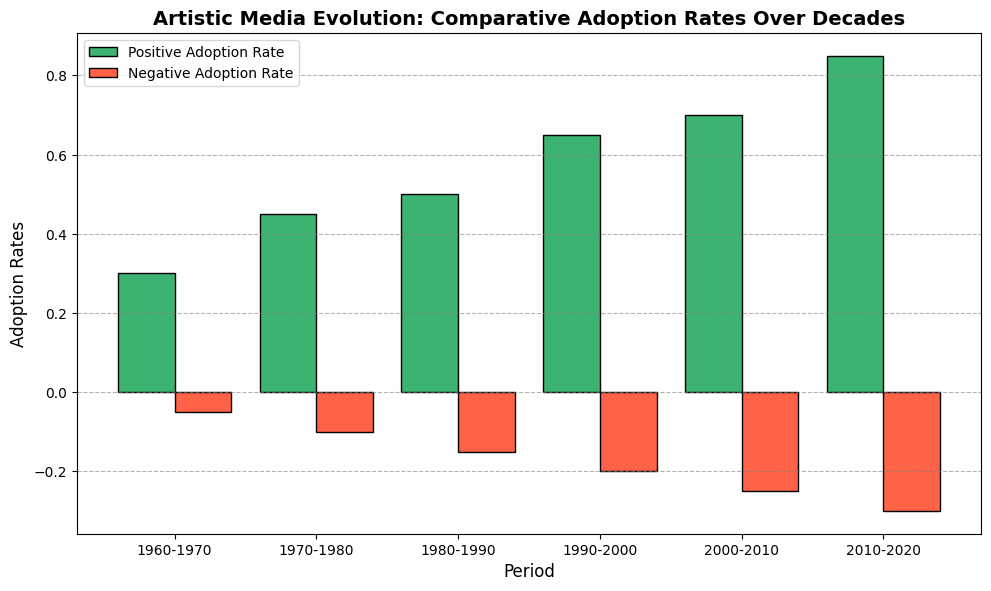How did the Positive Adoption Rate change from the 1960-1970 period to the 2010-2020 period? The Positive Adoption Rate in 1960-1970 was 0.30 and in 2010-2020 it was 0.85. Subtract 0.30 from 0.85 to find the change: 0.85 - 0.30 = 0.55
Answer: Increased by 0.55 During which period did the Negative Adoption Rate first exceed 0.20? By looking at the bar heights for negative adoption rates, the period 1990-2000 shows the Negative Adoption Rate reaching 0.20 for the first time
Answer: 1990-2000 What was the average Positive Adoption Rate across all periods? Add all the Positive Adoption Rates: 0.30 + 0.45 + 0.50 + 0.65 + 0.70 + 0.85, which equals 3.45. Divide by the number of periods, which is 6: 3.45 / 6 = 0.575
Answer: 0.575 Which period had the largest difference between Positive and Negative Adoption Rates? Calculate the differences for each period and compare:
- 1960-1970: 0.30 - 0.05 = 0.25
- 1970-1980: 0.45 - 0.10 = 0.35
- 1980-1990: 0.50 - 0.15 = 0.35
- 1990-2000: 0.65 - 0.20 = 0.45
- 2000-2010: 0.70 - 0.25 = 0.45
- 2010-2020: 0.85 - 0.30 = 0.55
The period with the greatest difference is 2010-2020
Answer: 2010-2020 How much did both Positive and Negative Adoption Rates increase from 1980-1990 to 1990-2000? - Positive Adoption Rate increased from 0.50 to 0.65: 0.65 - 0.50 = 0.15
- Negative Adoption Rate increased from 0.15 to 0.20: 0.20 - 0.15 = 0.05
Answer: Positive: 0.15, Negative: 0.05 What's the difference in Negative Adoption Rate between the period with the highest and the period with the lowest rate? The period with the highest Negative Adoption Rate is 2010-2020 at 0.30. The period with the lowest rate is 1960-1970 at 0.05. Subtract the lowest from the highest: 0.30 - 0.05 = 0.25
Answer: 0.25 Which periods have a Positive Adoption Rate less than 0.50? From the figure, the periods with a Positive Adoption Rate less than 0.50 are 1960-1970 (0.30) and 1970-1980 (0.45)
Answer: 1960-1970, 1970-1980 Is there any period where the Positive Adoption Rate is exactly double the Negative Adoption Rate? Compare the Positive Rates to twice the Negative Rates for each period:
- 1960-1970: 0.30 != 2*0.05
- 1970-1980: 0.45 != 2*0.10
- 1980-1990: 0.50 != 2*0.15
- 1990-2000: 0.65 != 2*0.20
- 2000-2010: 0.70 != 2*0.25
- 2010-2020: 0.85 != 2*0.30
None of the periods match this criterion
Answer: No 